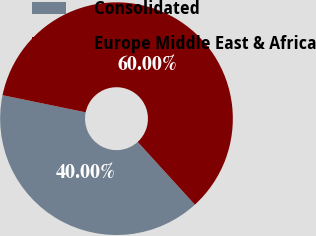Convert chart. <chart><loc_0><loc_0><loc_500><loc_500><pie_chart><fcel>Consolidated<fcel>Europe Middle East & Africa<nl><fcel>40.0%<fcel>60.0%<nl></chart> 